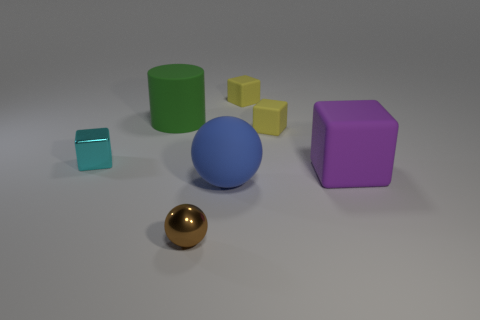Subtract all blocks. How many objects are left? 3 Subtract 4 cubes. How many cubes are left? 0 Subtract all yellow balls. Subtract all red cylinders. How many balls are left? 2 Subtract all blue balls. How many cyan blocks are left? 1 Subtract all cyan rubber objects. Subtract all rubber things. How many objects are left? 2 Add 4 brown balls. How many brown balls are left? 5 Add 3 blue matte spheres. How many blue matte spheres exist? 4 Add 2 small green cylinders. How many objects exist? 9 Subtract all cyan blocks. How many blocks are left? 3 Subtract all purple rubber cubes. How many cubes are left? 3 